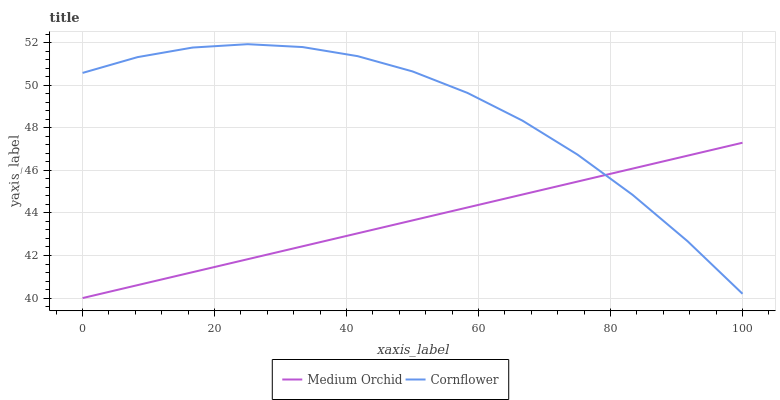Does Medium Orchid have the minimum area under the curve?
Answer yes or no. Yes. Does Cornflower have the maximum area under the curve?
Answer yes or no. Yes. Does Medium Orchid have the maximum area under the curve?
Answer yes or no. No. Is Medium Orchid the smoothest?
Answer yes or no. Yes. Is Cornflower the roughest?
Answer yes or no. Yes. Is Medium Orchid the roughest?
Answer yes or no. No. Does Medium Orchid have the lowest value?
Answer yes or no. Yes. Does Cornflower have the highest value?
Answer yes or no. Yes. Does Medium Orchid have the highest value?
Answer yes or no. No. Does Medium Orchid intersect Cornflower?
Answer yes or no. Yes. Is Medium Orchid less than Cornflower?
Answer yes or no. No. Is Medium Orchid greater than Cornflower?
Answer yes or no. No. 